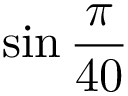<formula> <loc_0><loc_0><loc_500><loc_500>\sin { \frac { \pi } { 4 0 } }</formula> 